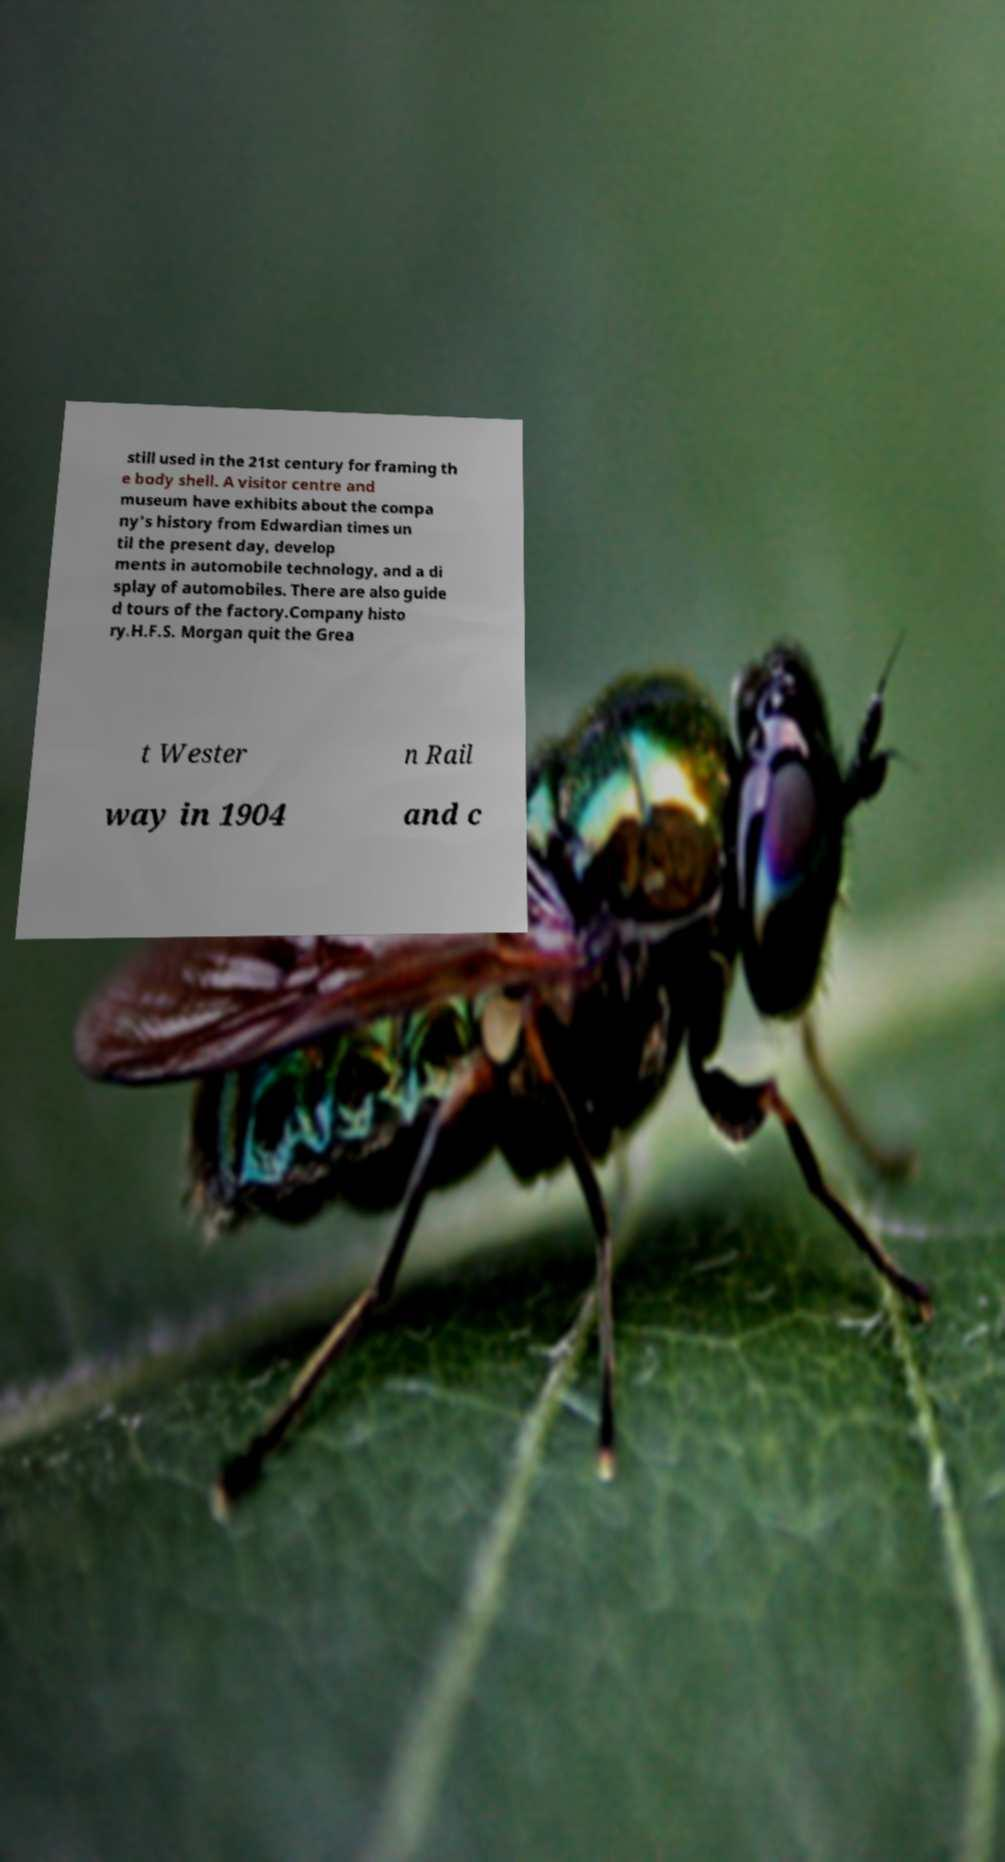Can you read and provide the text displayed in the image?This photo seems to have some interesting text. Can you extract and type it out for me? still used in the 21st century for framing th e body shell. A visitor centre and museum have exhibits about the compa ny's history from Edwardian times un til the present day, develop ments in automobile technology, and a di splay of automobiles. There are also guide d tours of the factory.Company histo ry.H.F.S. Morgan quit the Grea t Wester n Rail way in 1904 and c 